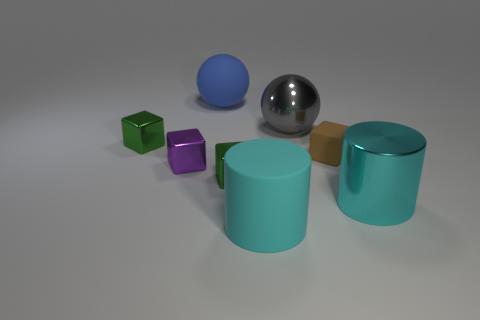Does the ball right of the blue thing have the same color as the metal cube behind the small purple cube?
Offer a terse response. No. What is the large cylinder left of the cyan cylinder right of the cyan matte cylinder made of?
Your answer should be very brief. Rubber. What is the color of the shiny cylinder that is the same size as the gray ball?
Keep it short and to the point. Cyan. There is a blue rubber thing; is its shape the same as the matte thing that is right of the cyan rubber cylinder?
Offer a terse response. No. The big object that is the same color as the large rubber cylinder is what shape?
Make the answer very short. Cylinder. There is a large matte object on the right side of the rubber ball to the left of the brown cube; how many gray objects are behind it?
Your answer should be very brief. 1. How big is the shiny sphere that is right of the big cyan cylinder that is to the left of the big gray shiny thing?
Your answer should be compact. Large. The brown block that is made of the same material as the blue object is what size?
Offer a very short reply. Small. The large thing that is both behind the big cyan metal object and in front of the big blue rubber thing has what shape?
Give a very brief answer. Sphere. Are there the same number of tiny matte things behind the blue rubber thing and large blue matte blocks?
Make the answer very short. Yes. 